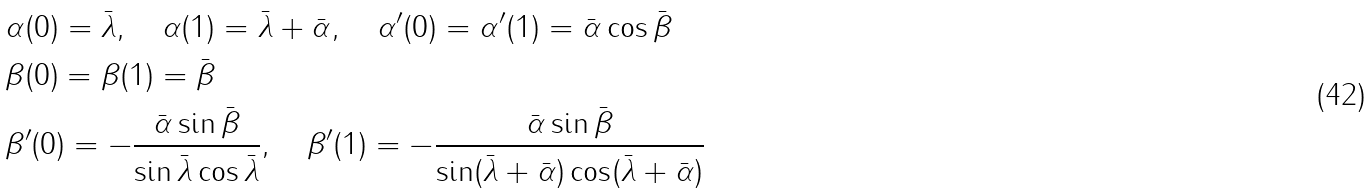<formula> <loc_0><loc_0><loc_500><loc_500>& \alpha ( 0 ) = \bar { \lambda } , \quad \alpha ( 1 ) = \bar { \lambda } + \bar { \alpha } , \quad \alpha ^ { \prime } ( 0 ) = \alpha ^ { \prime } ( 1 ) = \bar { \alpha } \cos \bar { \beta } \\ & \beta ( 0 ) = \beta ( 1 ) = \bar { \beta } \\ & \beta ^ { \prime } ( 0 ) = - \frac { \bar { \alpha } \sin \bar { \beta } } { \sin \bar { \lambda } \cos \bar { \lambda } } , \quad \beta ^ { \prime } ( 1 ) = - \frac { \bar { \alpha } \sin \bar { \beta } } { \sin ( \bar { \lambda } + \bar { \alpha } ) \cos ( \bar { \lambda } + \bar { \alpha } ) }</formula> 